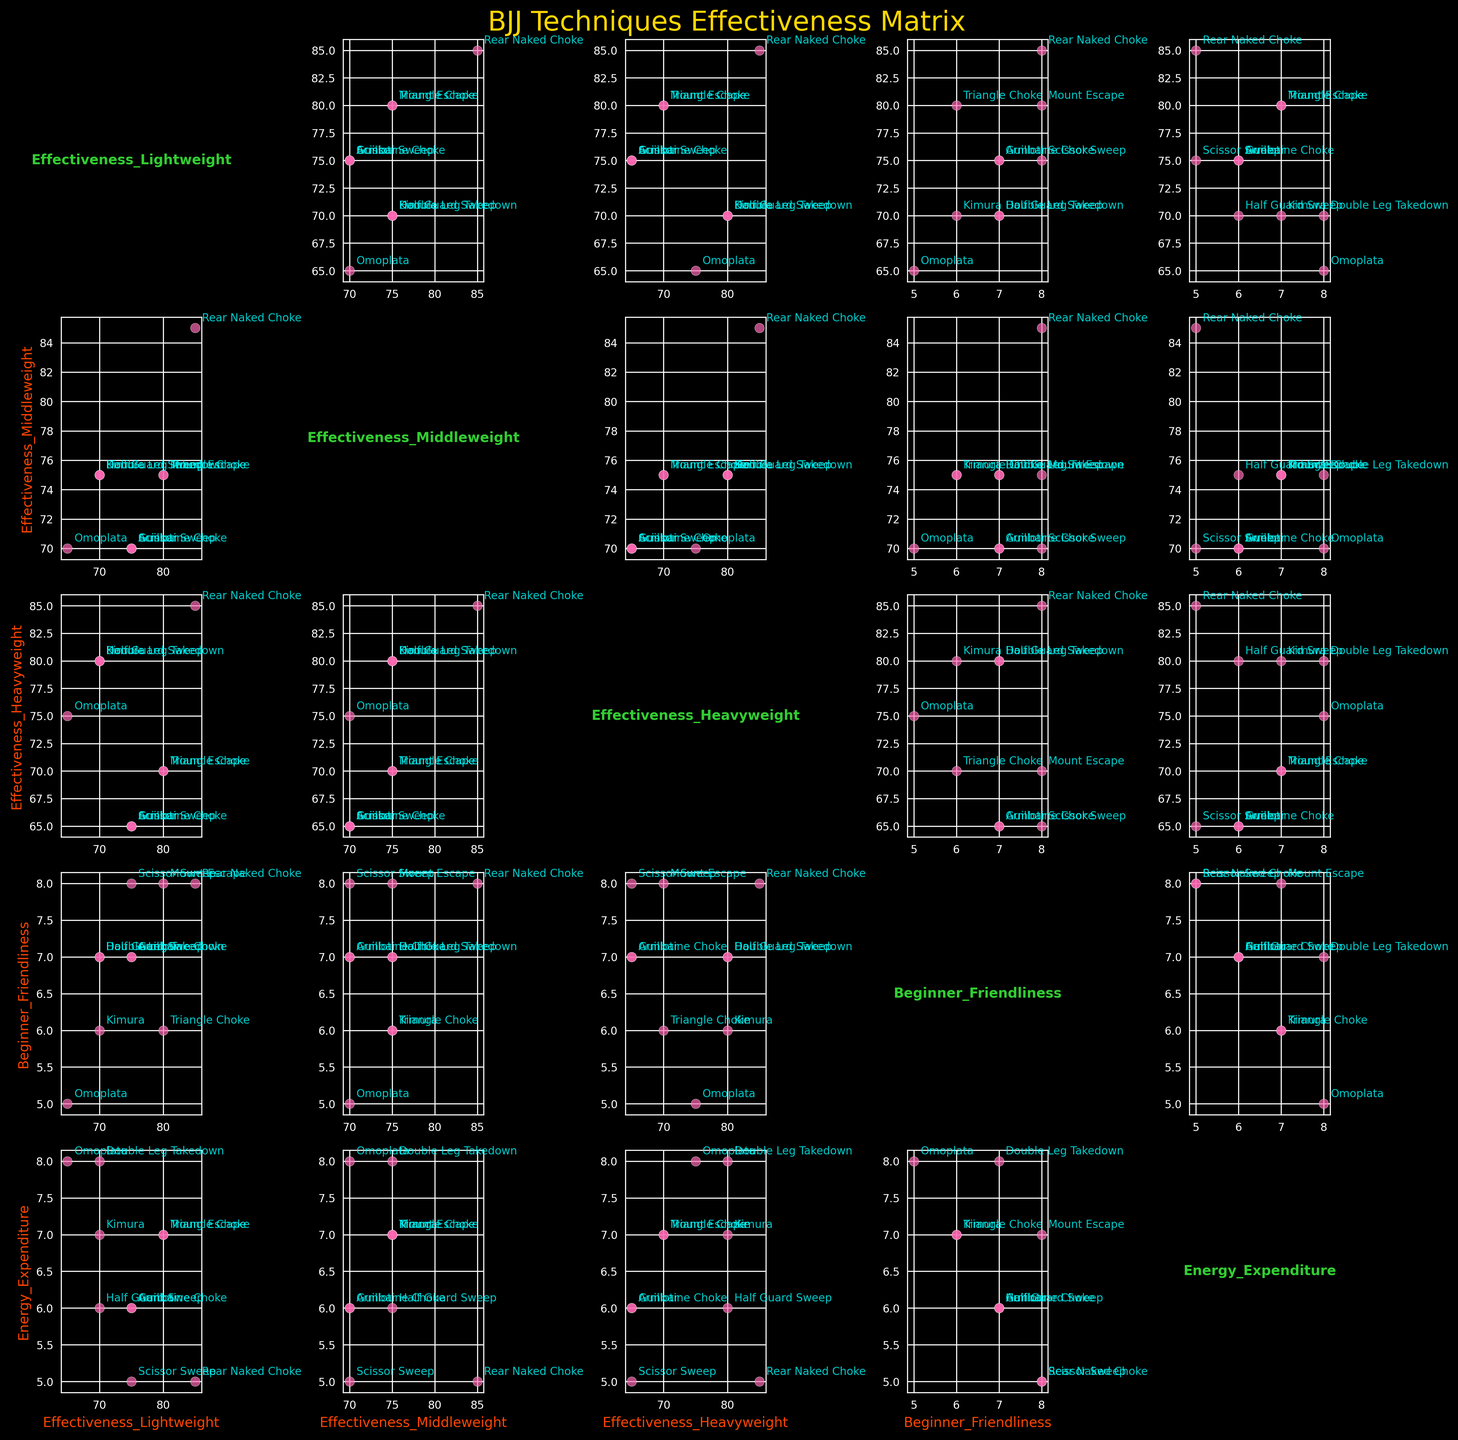What's the title of the figure? The title is generally displayed prominently at the top of the figure. In this plot, it is "BJJ Techniques Effectiveness Matrix"
Answer: BJJ Techniques Effectiveness Matrix What does the green text in each subplot represent? In the scatterplot matrix, the diagonal elements typically show the variable names. In this figure, the green text represents the names of the variables: Effectiveness_Lightweight, Effectiveness_Middleweight, Effectiveness_Heavyweight, Beginner_Friendliness, and Energy_Expenditure.
Answer: Variable names Which BJJ technique has the highest effectiveness across all weight classes? To find this, look across all the "Effectiveness" columns for each weight class and observe which technique consistently has high effectiveness values. The Rear Naked Choke scores 85 for Lightweight, Middleweight, and Heavyweight, which is the highest overall.
Answer: Rear Naked Choke Which technique is labeled with the highest point in the plot comparing Effectiveness_Middleweight to Energy_Expenditure? In the scatter plot comparing Effectiveness_Middleweight and Energy_Expenditure, observe the points and annotations. The Triangle Choke has the highest effectiveness of 75 with an energy expenditure of 7.
Answer: Triangle Choke Compare the Beginner_Friendliness and Energy_Expenditure of the Mount Escape technique. Which one is higher? Locate the Mount Escape technique's values for Beginner_Friendliness and Energy_Expenditure. Mount Escape has a Beginner_Friendliness score of 8 and an Energy_Expenditure score of 7. Since 8 is greater than 7, Beginner_Friendliness is higher.
Answer: Beginner_Friendliness What relationship do you observe in the scatter plot comparing Effectiveness_Lightweight and Beginner_Friendliness? In the scatter plot, the points represent different BJJ techniques. By visually inspecting, techniques with higher Beginner_Friendliness tend to also have higher Effectiveness_Lightweight, suggesting a positive correlation.
Answer: Positive correlation Which technique appears to be the most balanced in terms of effectiveness across different weight classes? Look for a technique with similar effectiveness scores across Lightweight, Middleweight, and Heavyweight. The Rear Naked Choke has an effectiveness of 85 across all weight classes, indicating balance.
Answer: Rear Naked Choke What is the average effectiveness of the Kimura technique across all weight classes? Sum the effectiveness levels of Kimura for Lightweight (70), Middleweight (75), and Heavyweight (80) and divide by the number of weight classes (3). (70 + 75 + 80) / 3 = 225 / 3 = 75.
Answer: 75 Is there a technique that has higher effectiveness for Heavyweight compared to Lightweight? By comparing the effectiveness scores for Heavyweight and Lightweight, the Kimura has an effectiveness of 80 for Heavyweight and 70 for Lightweight, which is higher for Heavyweight.
Answer: Kimura Which technique has the lowest energy expenditure, and how is it distributed across weight classes in terms of effectiveness? The technique with the lowest Energy_Expenditure is Rear Naked Choke with a value of 5. Its effectiveness is 85 across Lightweight, Middleweight, and Heavyweight.
Answer: Rear Naked Choke, uniformly high effectiveness 